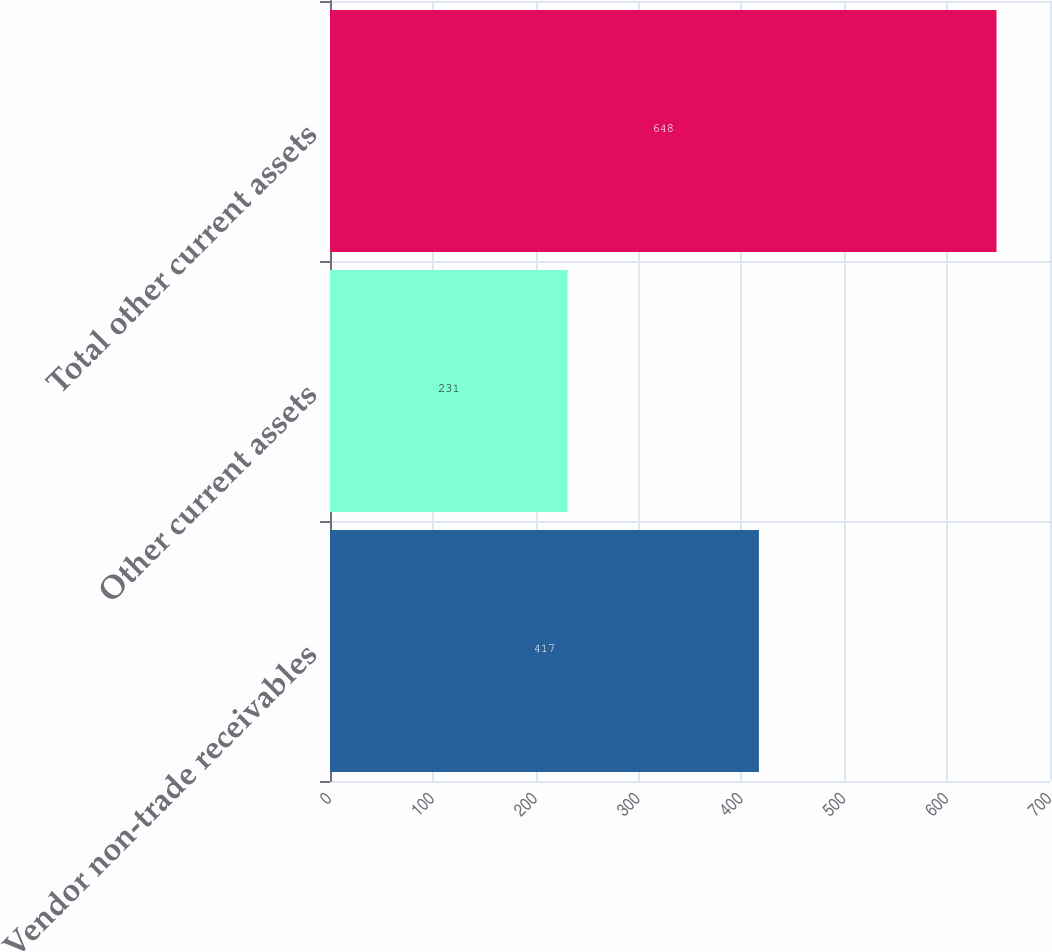Convert chart. <chart><loc_0><loc_0><loc_500><loc_500><bar_chart><fcel>Vendor non-trade receivables<fcel>Other current assets<fcel>Total other current assets<nl><fcel>417<fcel>231<fcel>648<nl></chart> 